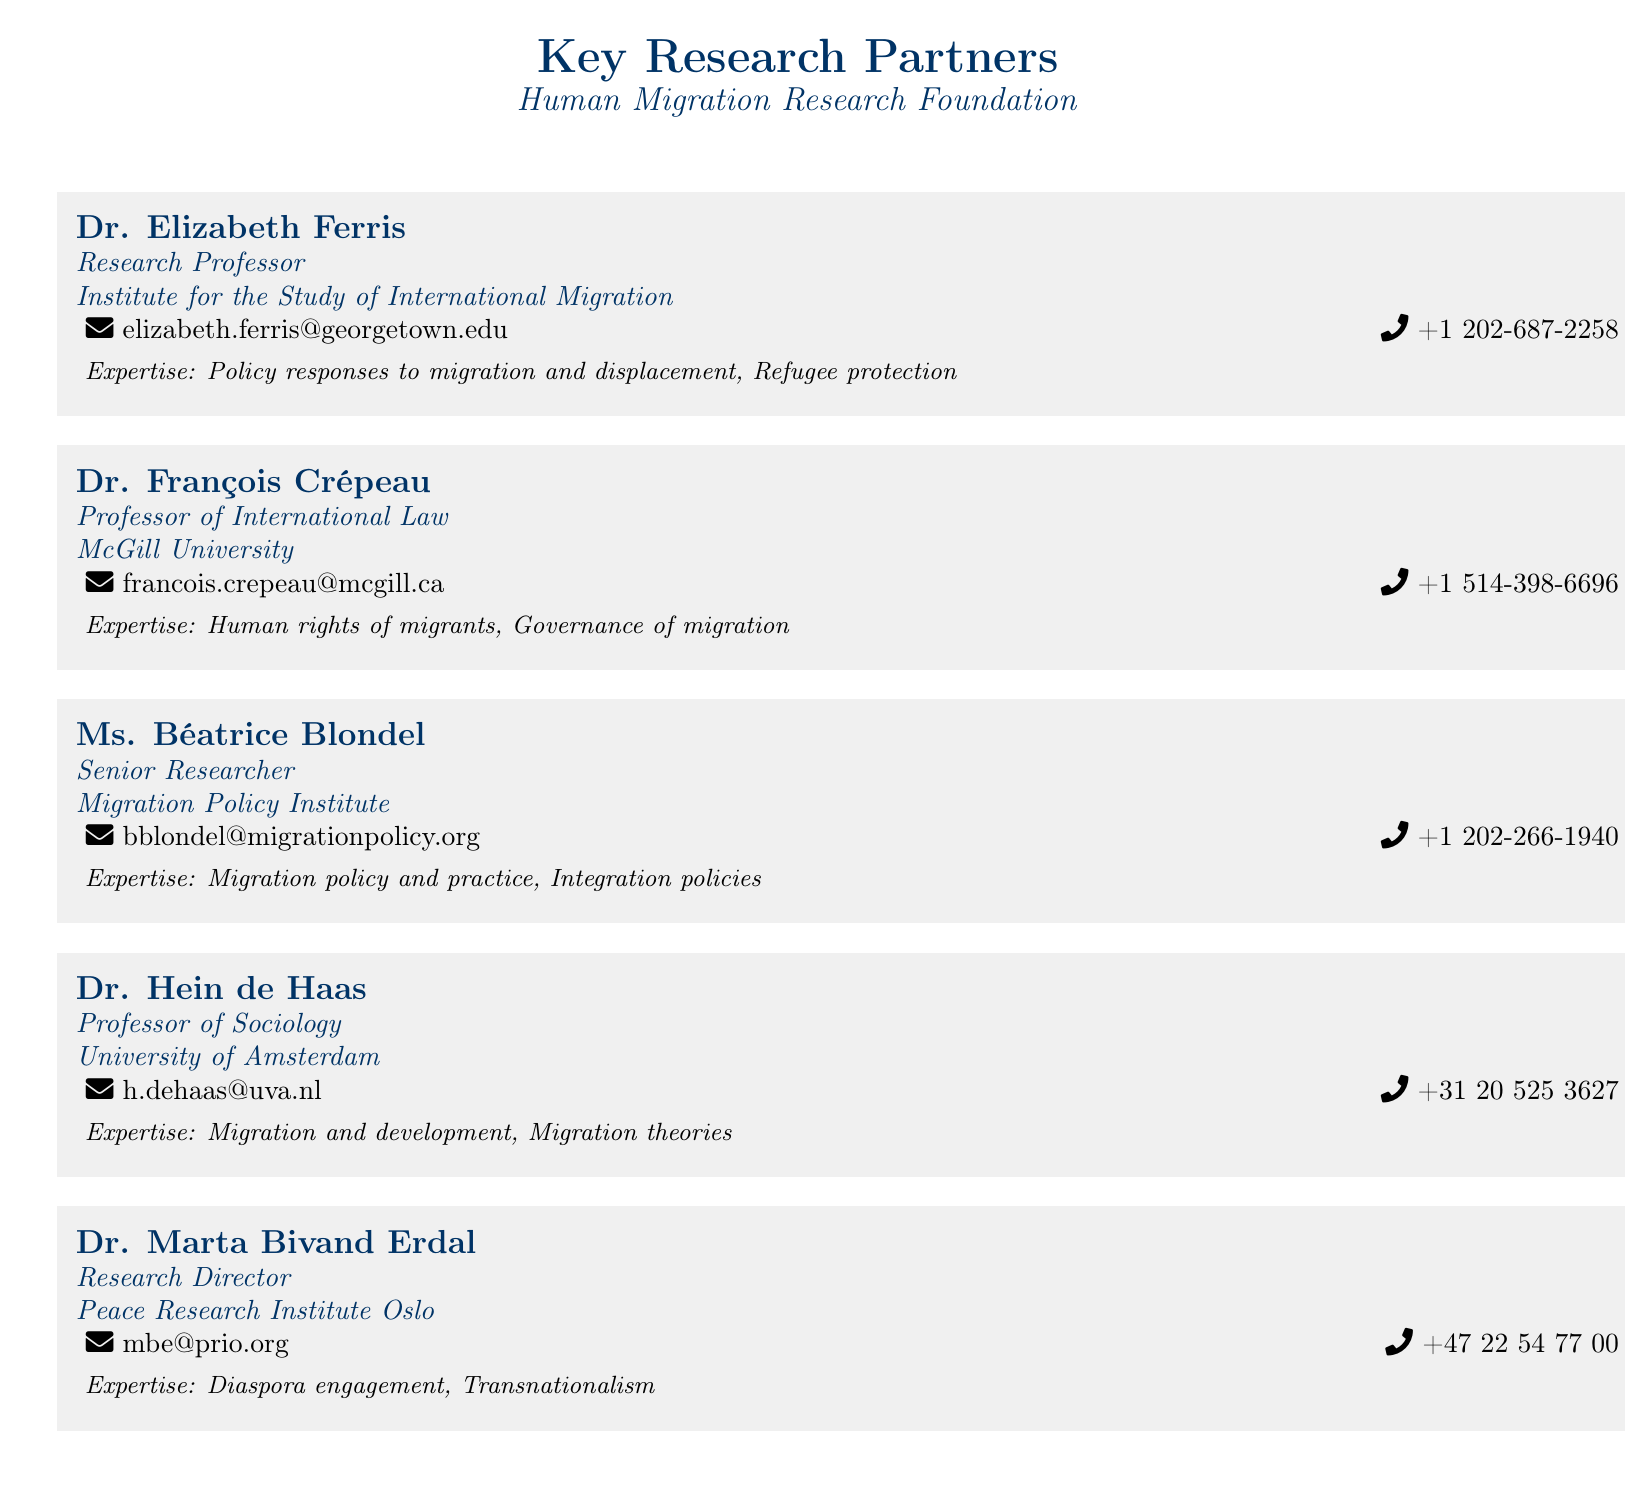What is the title of Dr. Elizabeth Ferris? The title of Dr. Elizabeth Ferris is "Research Professor" as listed in the contact information.
Answer: Research Professor What is Dr. François Crépeau's area of expertise? Dr. François Crépeau's area of expertise, as provided, is "Human rights of migrants, Governance of migration."
Answer: Human rights of migrants, Governance of migration Which institution is Ms. Béatrice Blondel affiliated with? Ms. Béatrice Blondel is affiliated with the "Migration Policy Institute" as stated in the document.
Answer: Migration Policy Institute What is the email address of Dr. Hein de Haas? The email address listed for Dr. Hein de Haas is contained in the contact information section.
Answer: h.dehaas@uva.nl How many researchers are listed in the document? The document lists five researchers, based on the provided contact information.
Answer: Five Which researcher specializes in transnationalism? The specialization in transnationalism is mentioned under Dr. Marta Bivand Erdal's expertise.
Answer: Dr. Marta Bivand Erdal What is the phone number of Ms. Béatrice Blondel? The phone number listed for Ms. Béatrice Blondel can be found in her contact information.
Answer: +1 202-266-1940 What type of document is this? The document is a collection of business cards showcasing key research partners.
Answer: Business cards What is the purpose of this document? The document serves to provide contact information for key research partners associated with the Human Migration Research Foundation.
Answer: Contact information for key research partners 